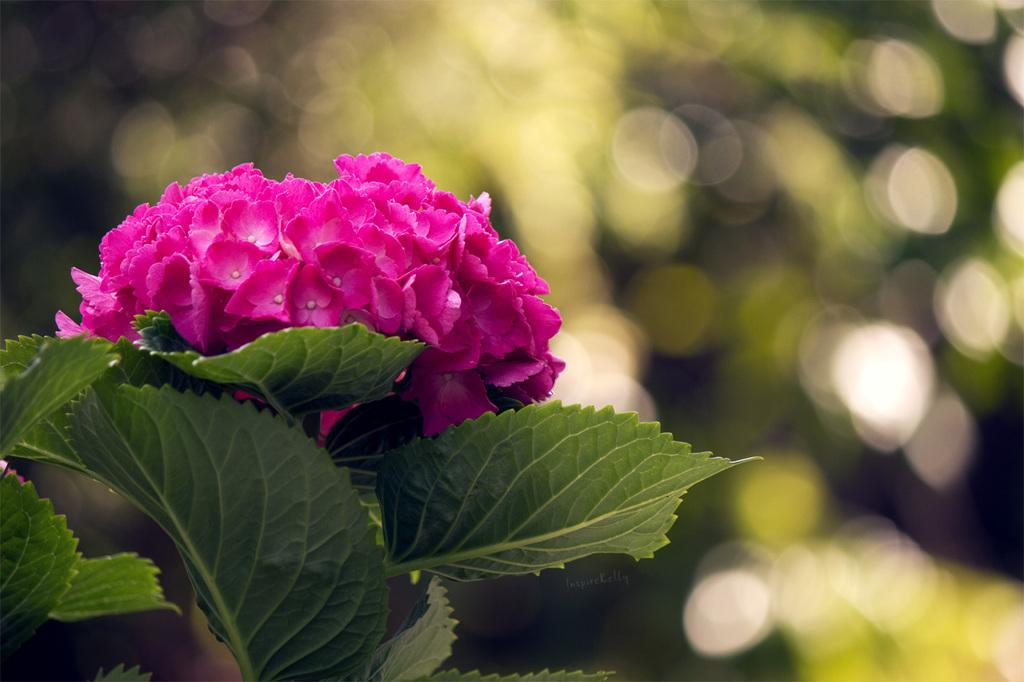What type of flower is present in the image? There is a pink color flower in the image. Where is the flower located? The flower is on a plant. Can you describe the quality of the image? The image is blurry at the back. What news is being discussed by the flower in the image? There is no indication in the image that the flower is discussing any news. How does the flower say good-bye to the other flowers in the image? There are no other flowers present in the image, so it is not possible to determine how the flower might say good-bye. 